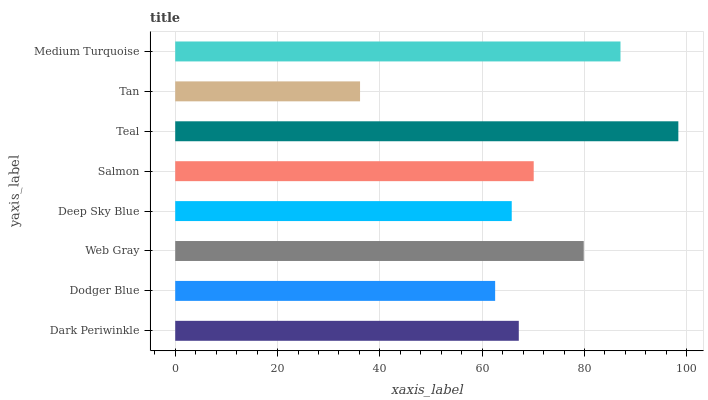Is Tan the minimum?
Answer yes or no. Yes. Is Teal the maximum?
Answer yes or no. Yes. Is Dodger Blue the minimum?
Answer yes or no. No. Is Dodger Blue the maximum?
Answer yes or no. No. Is Dark Periwinkle greater than Dodger Blue?
Answer yes or no. Yes. Is Dodger Blue less than Dark Periwinkle?
Answer yes or no. Yes. Is Dodger Blue greater than Dark Periwinkle?
Answer yes or no. No. Is Dark Periwinkle less than Dodger Blue?
Answer yes or no. No. Is Salmon the high median?
Answer yes or no. Yes. Is Dark Periwinkle the low median?
Answer yes or no. Yes. Is Dark Periwinkle the high median?
Answer yes or no. No. Is Teal the low median?
Answer yes or no. No. 